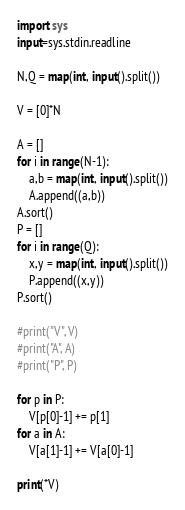Convert code to text. <code><loc_0><loc_0><loc_500><loc_500><_Python_>import sys
input=sys.stdin.readline

N,Q = map(int, input().split())

V = [0]*N

A = []
for i in range(N-1):
    a,b = map(int, input().split())
    A.append((a,b))
A.sort()
P = []
for i in range(Q):
    x,y = map(int, input().split())
    P.append((x,y))
P.sort()

#print("V", V)
#print("A", A)
#print("P", P)

for p in P:
    V[p[0]-1] += p[1]
for a in A:
    V[a[1]-1] += V[a[0]-1]

print(*V)
</code> 